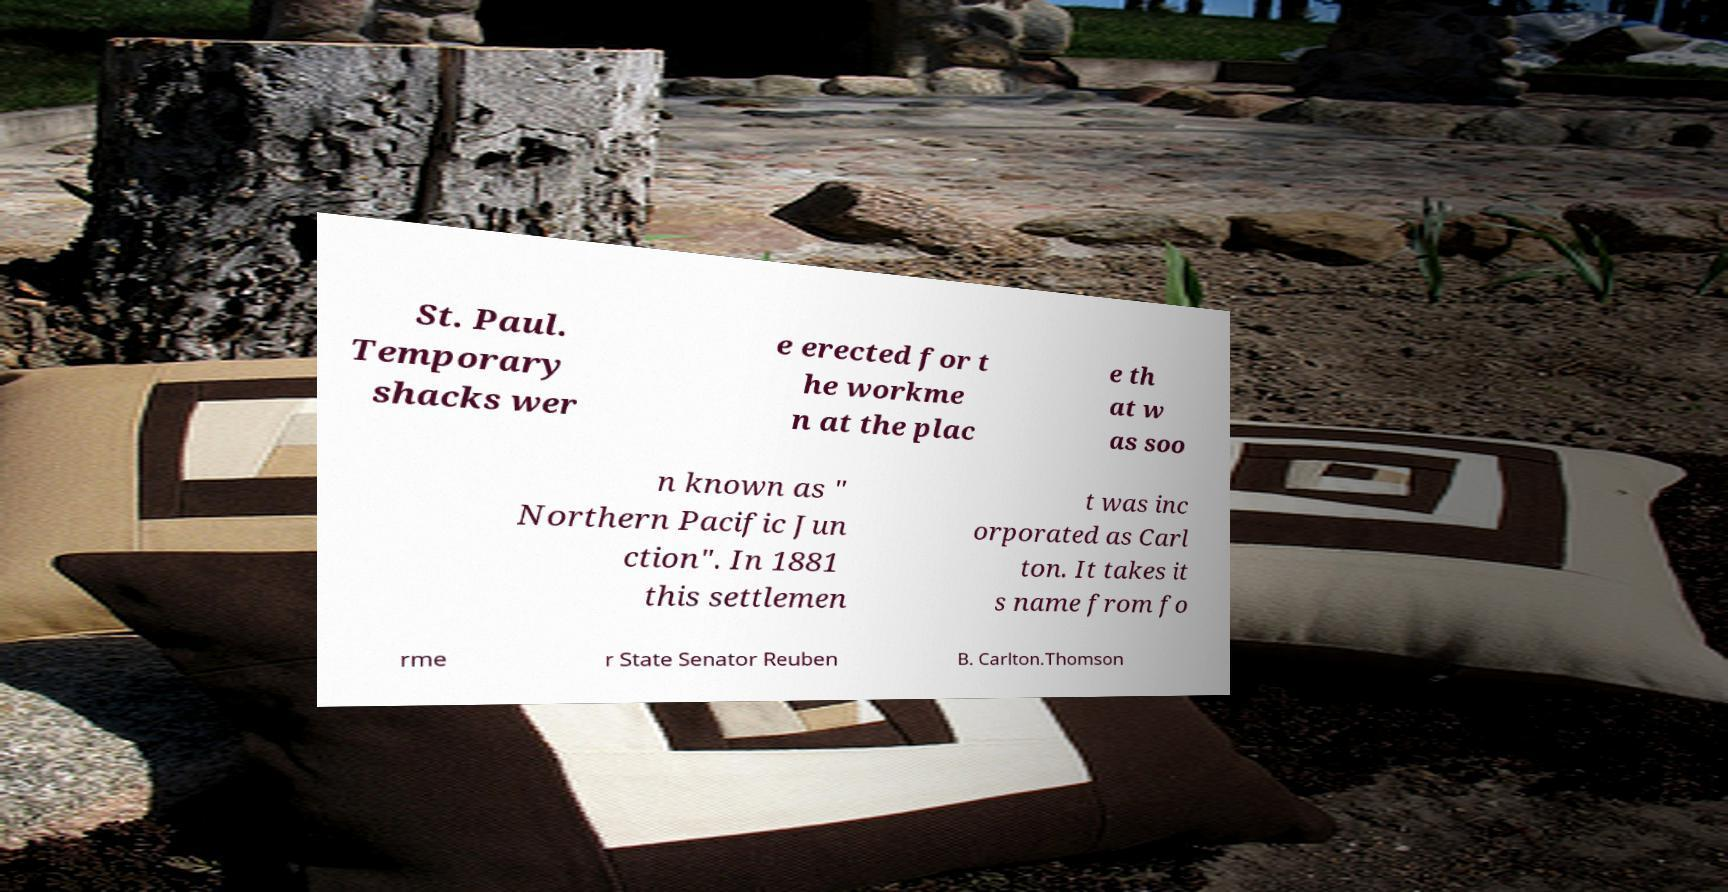Please identify and transcribe the text found in this image. St. Paul. Temporary shacks wer e erected for t he workme n at the plac e th at w as soo n known as " Northern Pacific Jun ction". In 1881 this settlemen t was inc orporated as Carl ton. It takes it s name from fo rme r State Senator Reuben B. Carlton.Thomson 